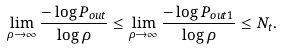Convert formula to latex. <formula><loc_0><loc_0><loc_500><loc_500>\lim _ { \rho \rightarrow \infty } \frac { - \log P _ { o u t } } { \log \rho } \leq \lim _ { \rho \rightarrow \infty } \frac { - \log P _ { o u t 1 } } { \log \rho } \leq N _ { t } .</formula> 